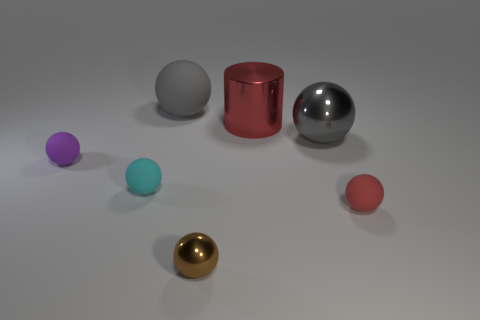Subtract all balls. How many objects are left? 1 Add 7 cyan matte things. How many cyan matte things exist? 8 Add 3 large cyan things. How many objects exist? 10 Subtract all gray spheres. How many spheres are left? 4 Subtract all small brown spheres. How many spheres are left? 5 Subtract 1 red cylinders. How many objects are left? 6 Subtract 5 balls. How many balls are left? 1 Subtract all brown balls. Subtract all cyan cubes. How many balls are left? 5 Subtract all blue cubes. How many red spheres are left? 1 Subtract all small green metal objects. Subtract all gray objects. How many objects are left? 5 